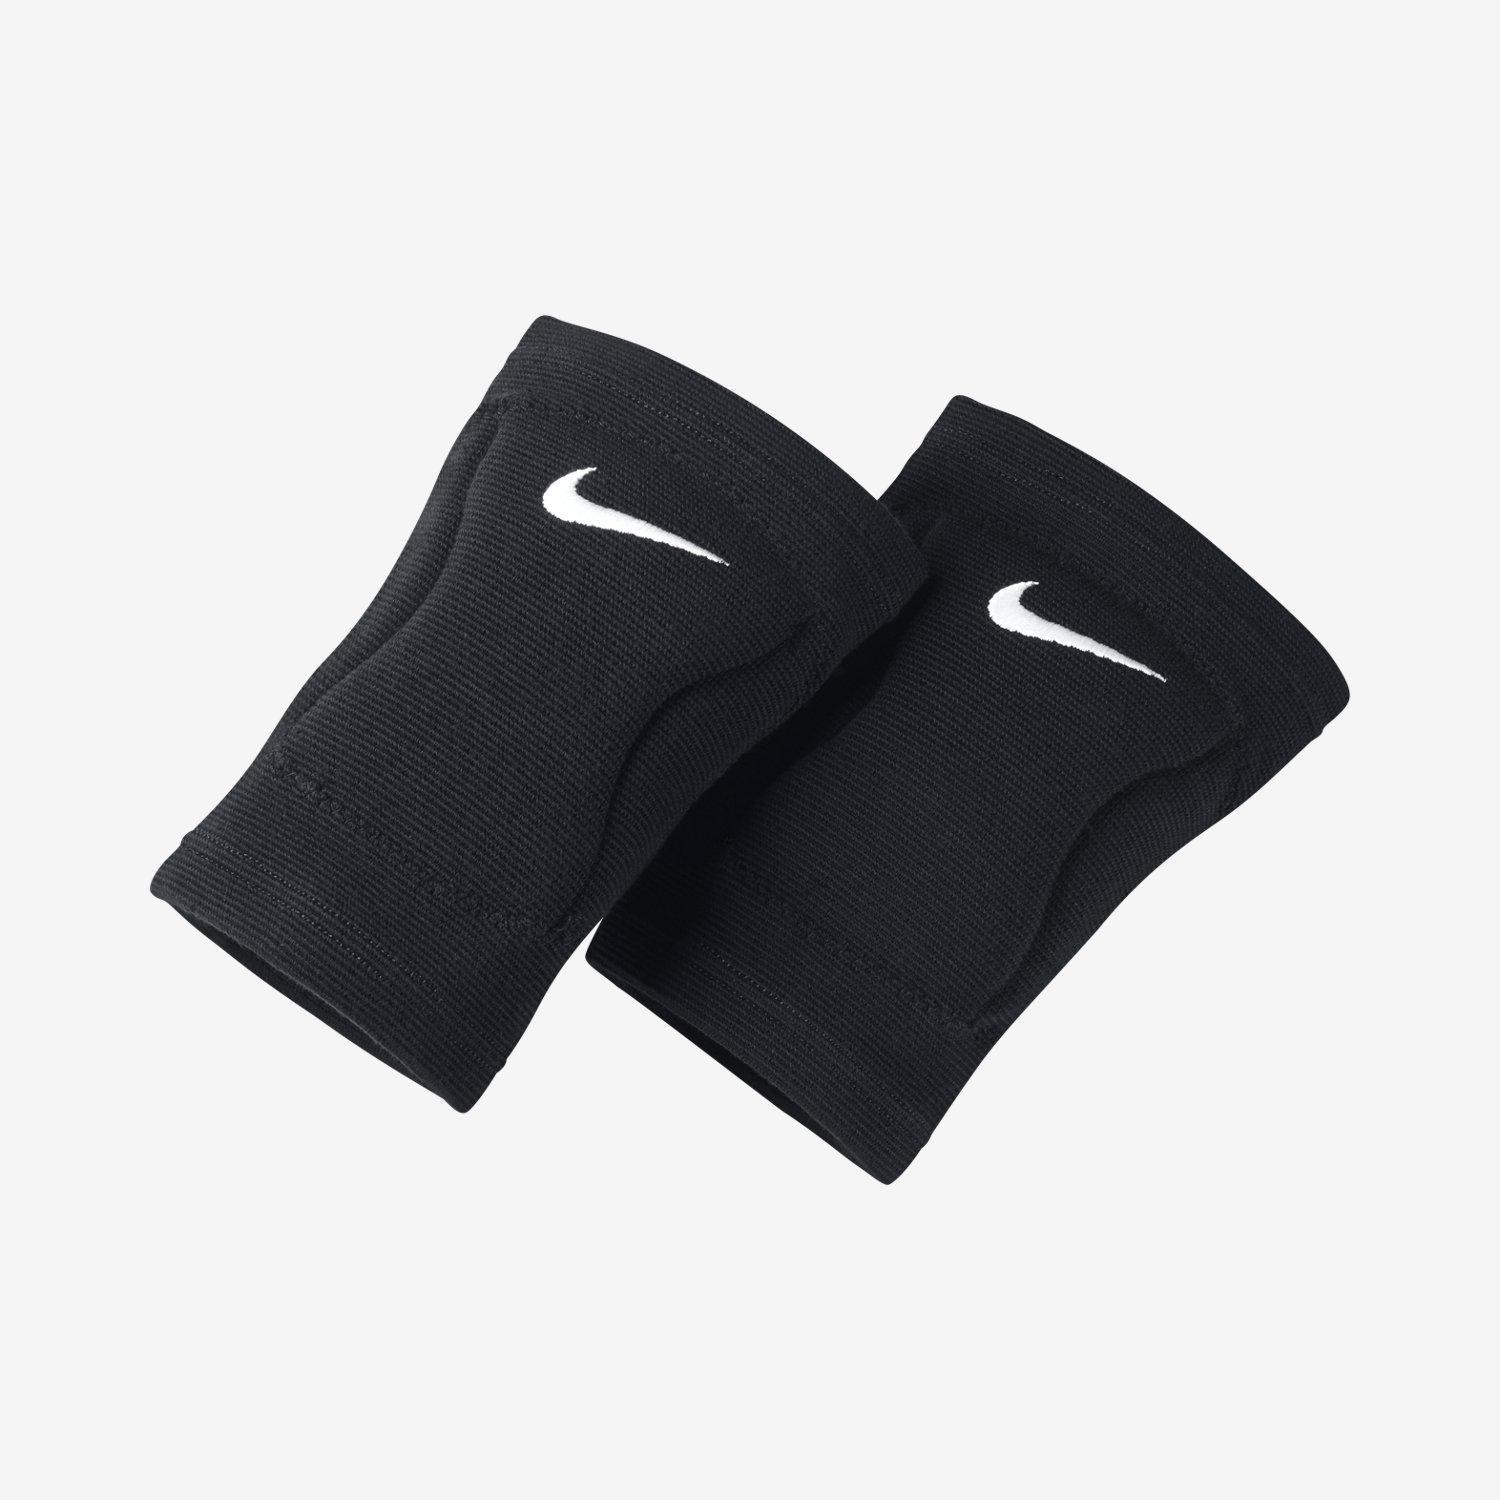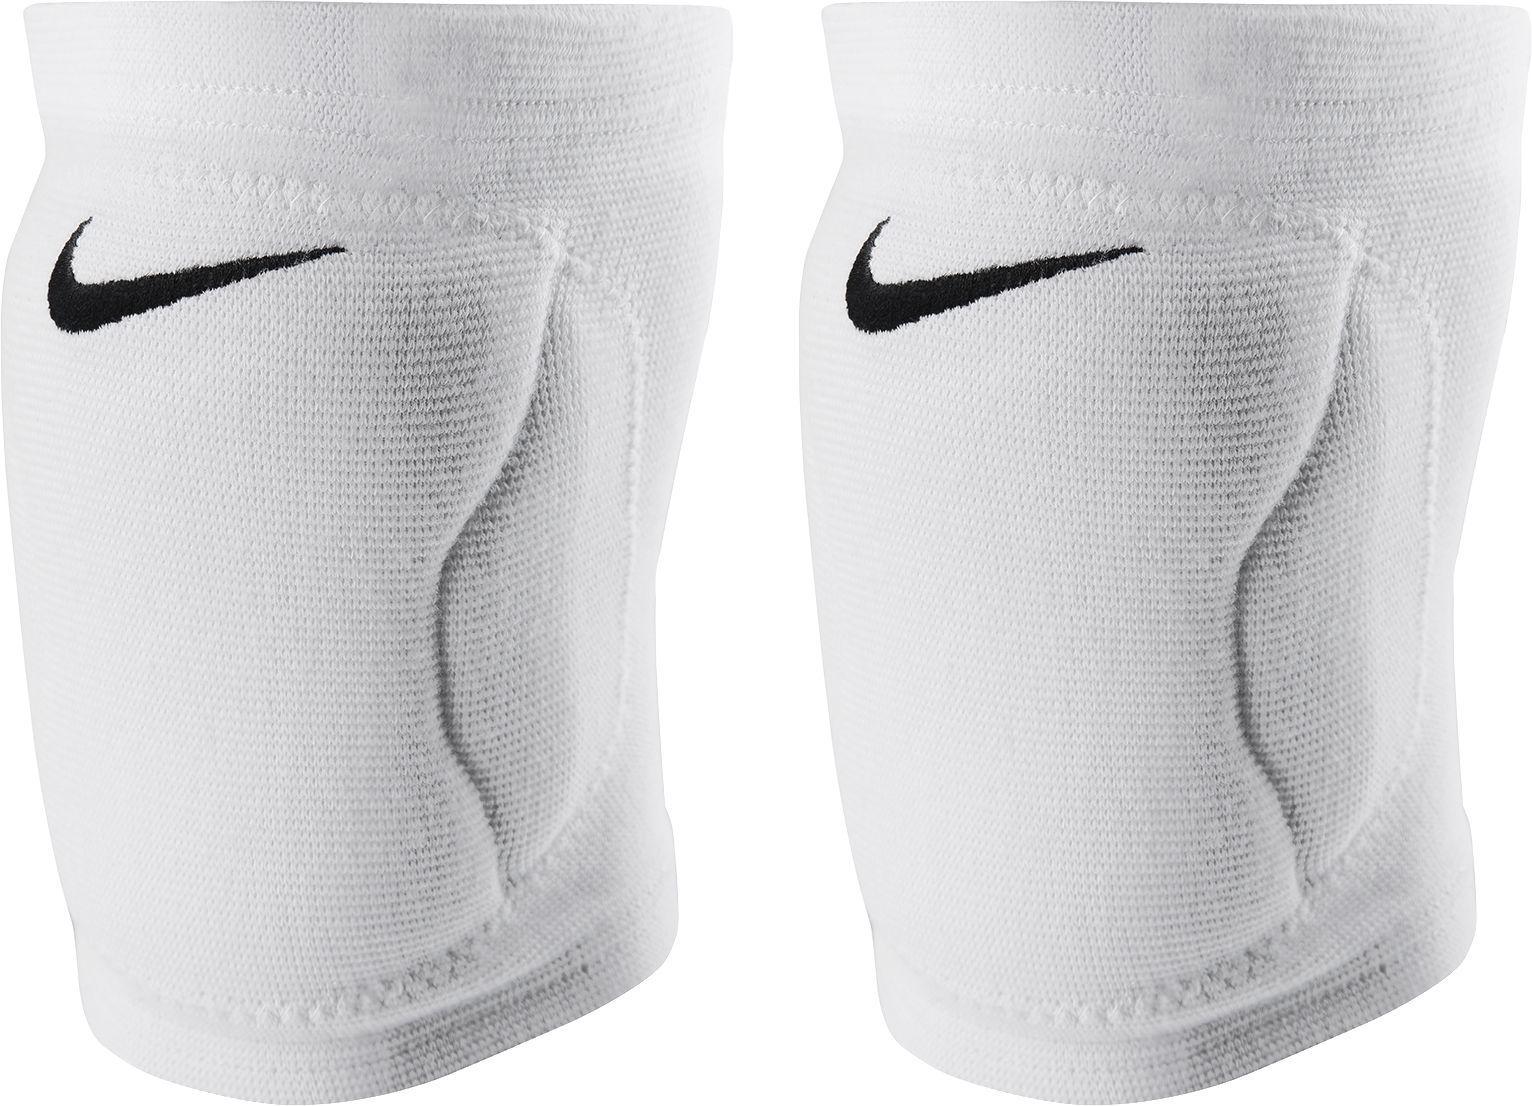The first image is the image on the left, the second image is the image on the right. Examine the images to the left and right. Is the description "At least one pair of kneepads is worn by a human." accurate? Answer yes or no. No. The first image is the image on the left, the second image is the image on the right. Evaluate the accuracy of this statement regarding the images: "There are three black knee braces and one white knee brace.". Is it true? Answer yes or no. No. The first image is the image on the left, the second image is the image on the right. Given the left and right images, does the statement "Three of the four total knee pads are black" hold true? Answer yes or no. No. The first image is the image on the left, the second image is the image on the right. Assess this claim about the two images: "One image shows one each of white and black knee pads.". Correct or not? Answer yes or no. No. 